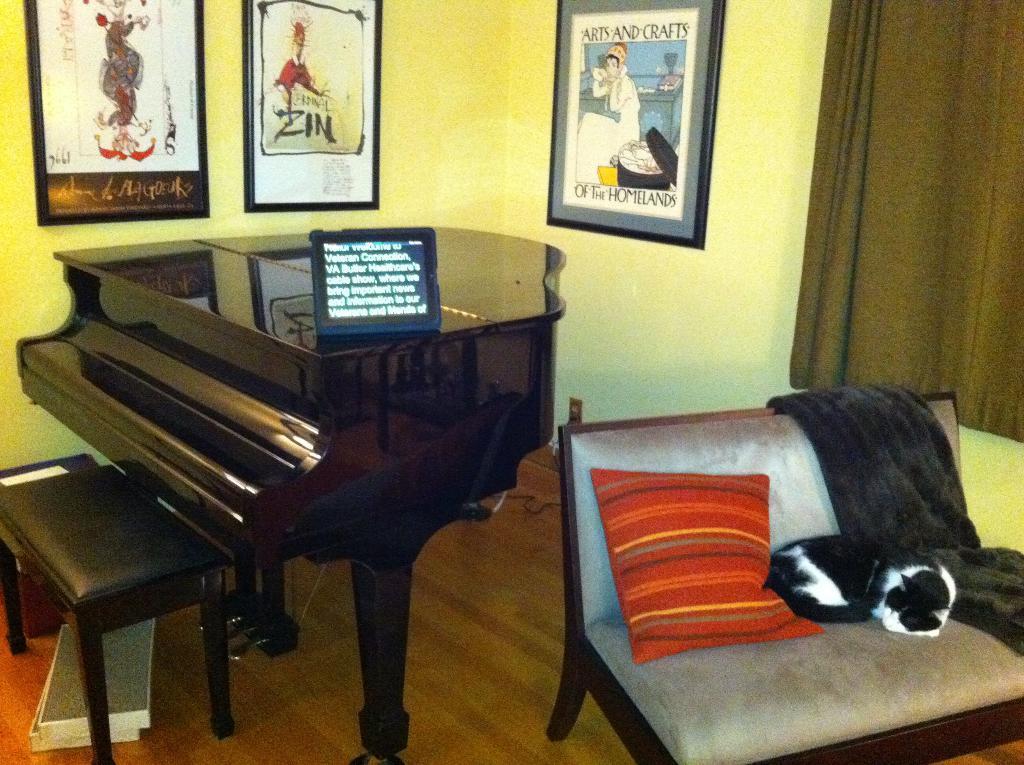In one or two sentences, can you explain what this image depicts? Here we can see a piano and a stool and at the right side we can see a chair with cushion and cat on it, at the top right side we can see a curtain at the walls we can see portraits 